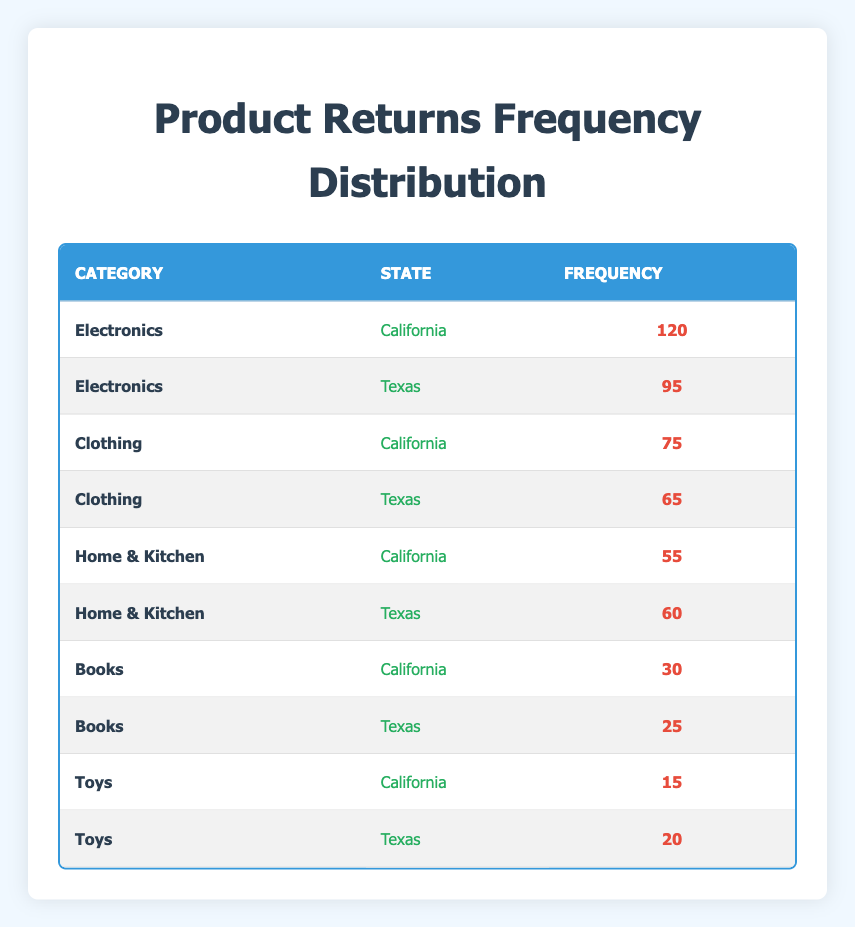What is the frequency of product returns for Electronics in California? The table clearly shows that for the Electronics category, the frequency of returns in California is listed as 120.
Answer: 120 Which category has the highest frequency of returns across both states? To find the category with the highest frequency across states, we can compare the frequencies: Electronics (120 in California + 95 in Texas = 215), Clothing (75 + 65 = 140), Home & Kitchen (55 + 60 = 115), Books (30 + 25 = 55), Toys (15 + 20 = 35). The highest total is for Electronics with 215.
Answer: Electronics What is the total frequency of returns for Clothing in both states? The frequency for Clothing in California is 75 and in Texas is 65. Adding these gives 75 + 65 = 140 for a total frequency of returns for Clothing.
Answer: 140 Is the frequency of returns for Home & Kitchen higher in Texas than in California? The frequency for Home & Kitchen in California is 55 and in Texas is 60. Since 60 is greater than 55, the frequency in Texas is indeed higher.
Answer: Yes What is the total frequency of product returns across all categories in Texas? To find the total frequency in Texas, we add the frequencies of all categories for that state: Electronics (95) + Clothing (65) + Home & Kitchen (60) + Books (25) + Toys (20) = 95 + 65 + 60 + 25 + 20 = 265.
Answer: 265 Which state has a higher total frequency of product returns: California or Texas? Calculating totals: California has 120 (Electronics) + 75 (Clothing) + 55 (Home & Kitchen) + 30 (Books) + 15 (Toys) = 295. Texas has 95 (Electronics) + 65 (Clothing) + 60 (Home & Kitchen) + 25 (Books) + 20 (Toys) = 265. Since 295 > 265, California has a higher total.
Answer: California Which category had the fewest returns overall? First, we will sum the frequencies for each category: Electronics (215), Clothing (140), Home & Kitchen (115), Books (55), and Toys (35). The fewest returns are from Toys with a total of 35.
Answer: Toys What is the difference in the frequency of returns for Books between California and Texas? The frequency for Books in California is 30 and in Texas is 25. Subtracting these gives 30 - 25 = 5.
Answer: 5 Which state had more product returns for Toys? The frequency for Toys in California is 15 and in Texas is 20. Since 20 is greater than 15, Texas had more returns for Toys.
Answer: Texas 